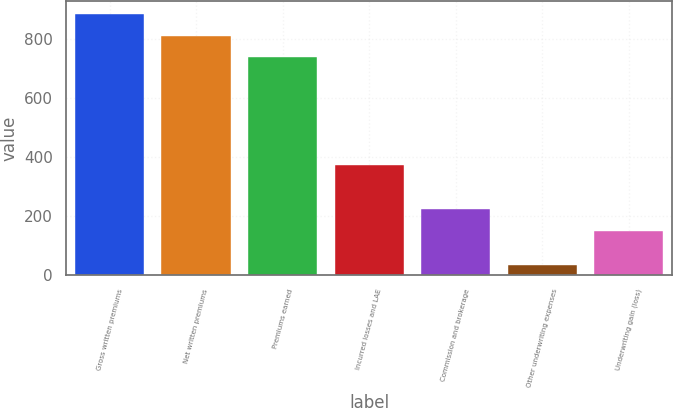Convert chart to OTSL. <chart><loc_0><loc_0><loc_500><loc_500><bar_chart><fcel>Gross written premiums<fcel>Net written premiums<fcel>Premiums earned<fcel>Incurred losses and LAE<fcel>Commission and brokerage<fcel>Other underwriting expenses<fcel>Underwriting gain (loss)<nl><fcel>885.92<fcel>811.96<fcel>738<fcel>374.4<fcel>223.76<fcel>34.7<fcel>149.8<nl></chart> 